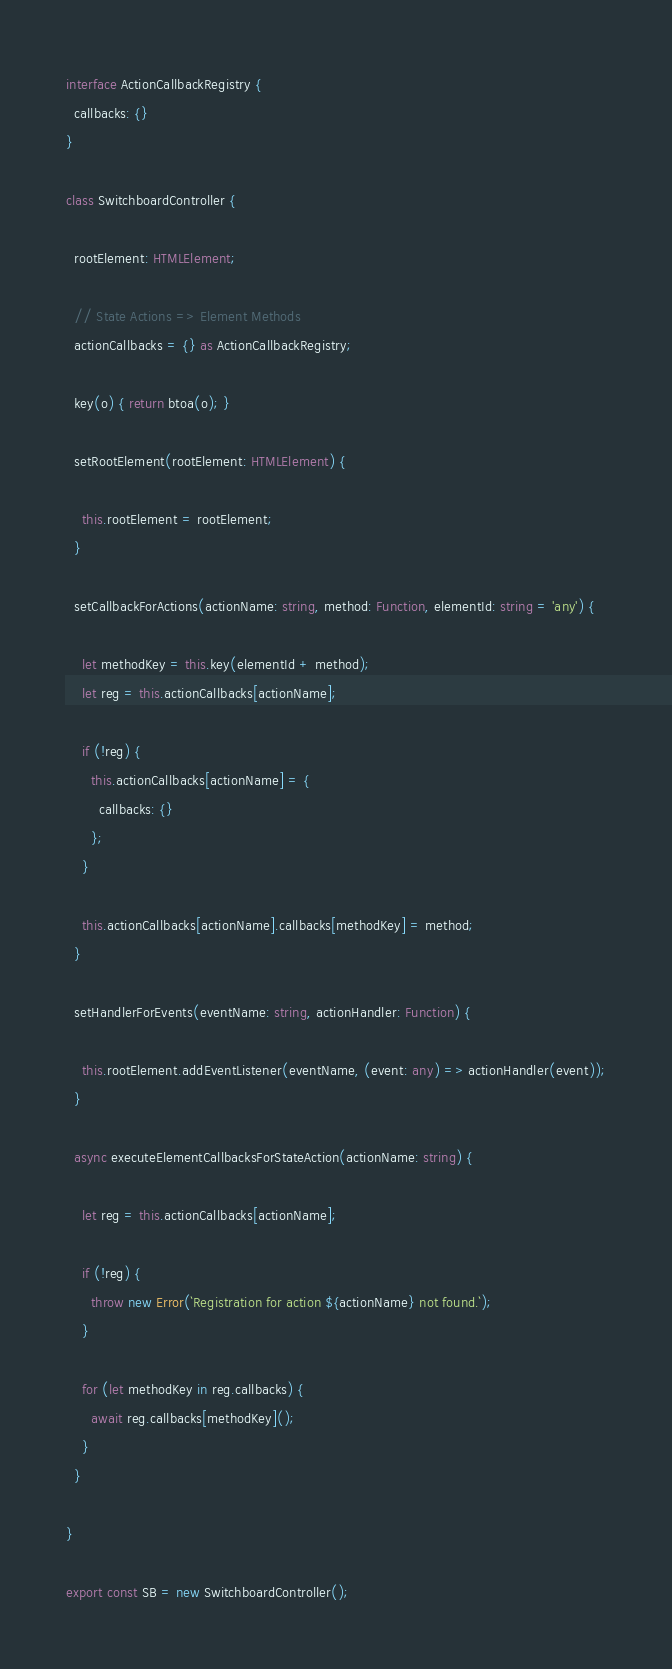<code> <loc_0><loc_0><loc_500><loc_500><_TypeScript_>interface ActionCallbackRegistry {
  callbacks: {}
}

class SwitchboardController {

  rootElement: HTMLElement;

  // State Actions => Element Methods
  actionCallbacks = {} as ActionCallbackRegistry;

  key(o) { return btoa(o); }

  setRootElement(rootElement: HTMLElement) {

    this.rootElement = rootElement;
  }

  setCallbackForActions(actionName: string, method: Function, elementId: string = 'any') {

    let methodKey = this.key(elementId + method);
    let reg = this.actionCallbacks[actionName];

    if (!reg) {
      this.actionCallbacks[actionName] = {
        callbacks: {}
      };
    }

    this.actionCallbacks[actionName].callbacks[methodKey] = method;
  }

  setHandlerForEvents(eventName: string, actionHandler: Function) {

    this.rootElement.addEventListener(eventName, (event: any) => actionHandler(event));
  }

  async executeElementCallbacksForStateAction(actionName: string) {

    let reg = this.actionCallbacks[actionName];

    if (!reg) {
      throw new Error(`Registration for action ${actionName} not found.`);
    }

    for (let methodKey in reg.callbacks) {
      await reg.callbacks[methodKey]();
    }
  }

}

export const SB = new SwitchboardController();</code> 